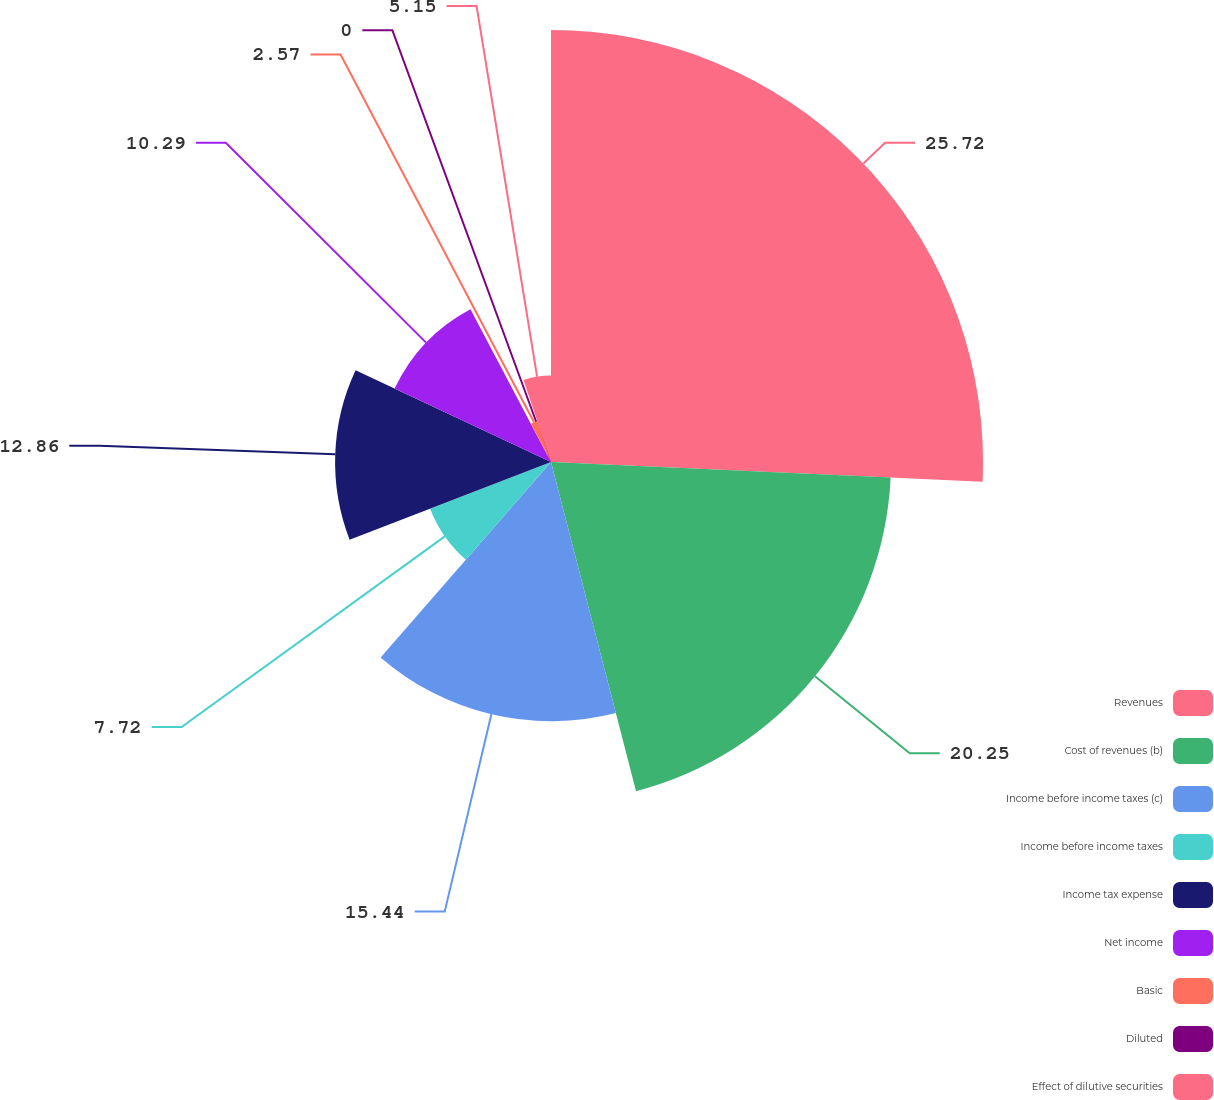Convert chart. <chart><loc_0><loc_0><loc_500><loc_500><pie_chart><fcel>Revenues<fcel>Cost of revenues (b)<fcel>Income before income taxes (c)<fcel>Income before income taxes<fcel>Income tax expense<fcel>Net income<fcel>Basic<fcel>Diluted<fcel>Effect of dilutive securities<nl><fcel>25.73%<fcel>20.25%<fcel>15.44%<fcel>7.72%<fcel>12.86%<fcel>10.29%<fcel>2.57%<fcel>0.0%<fcel>5.15%<nl></chart> 